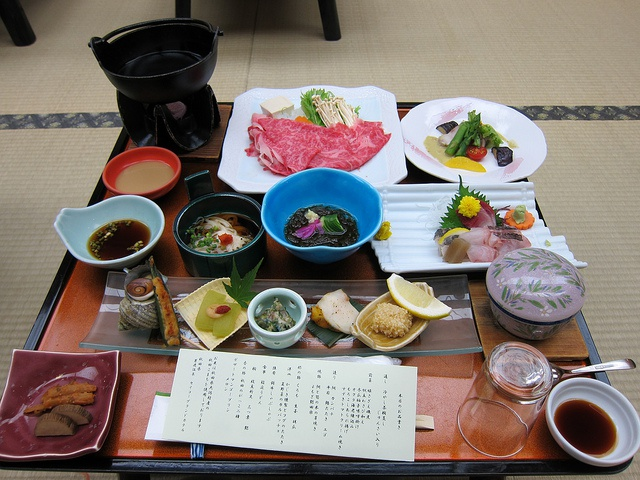Describe the objects in this image and their specific colors. I can see dining table in black, lightgray, gray, and brown tones, bowl in black, blue, gray, and teal tones, bowl in black and gray tones, cup in black, brown, darkgray, and maroon tones, and bowl in black, darkgray, and gray tones in this image. 